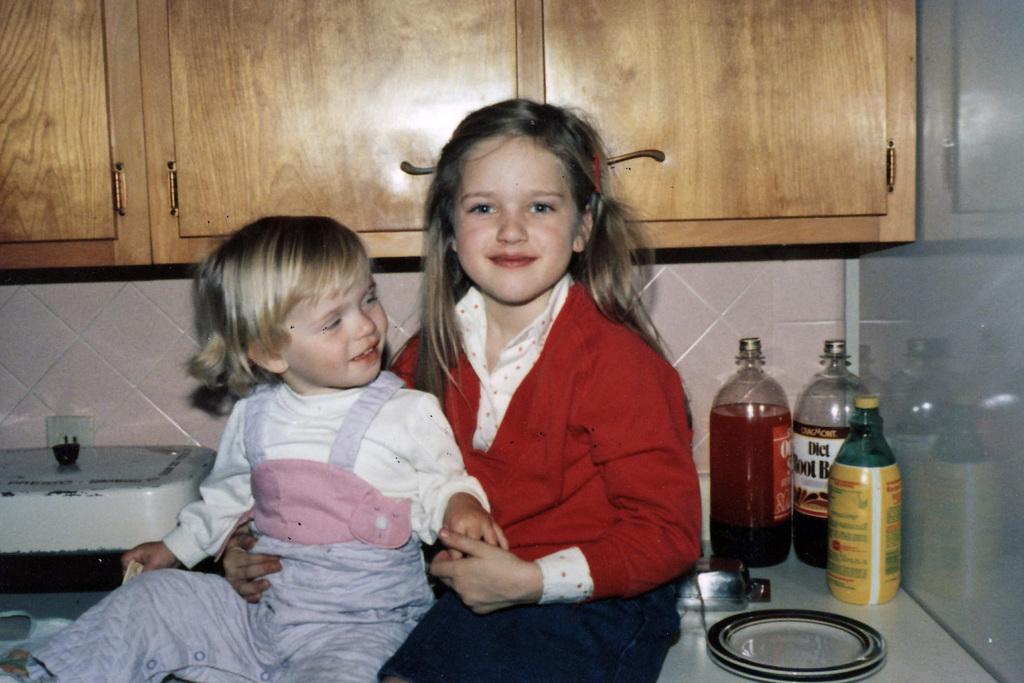What is one of the words mentioned on one of the bottles behind the children?
Your answer should be compact. Diet. 